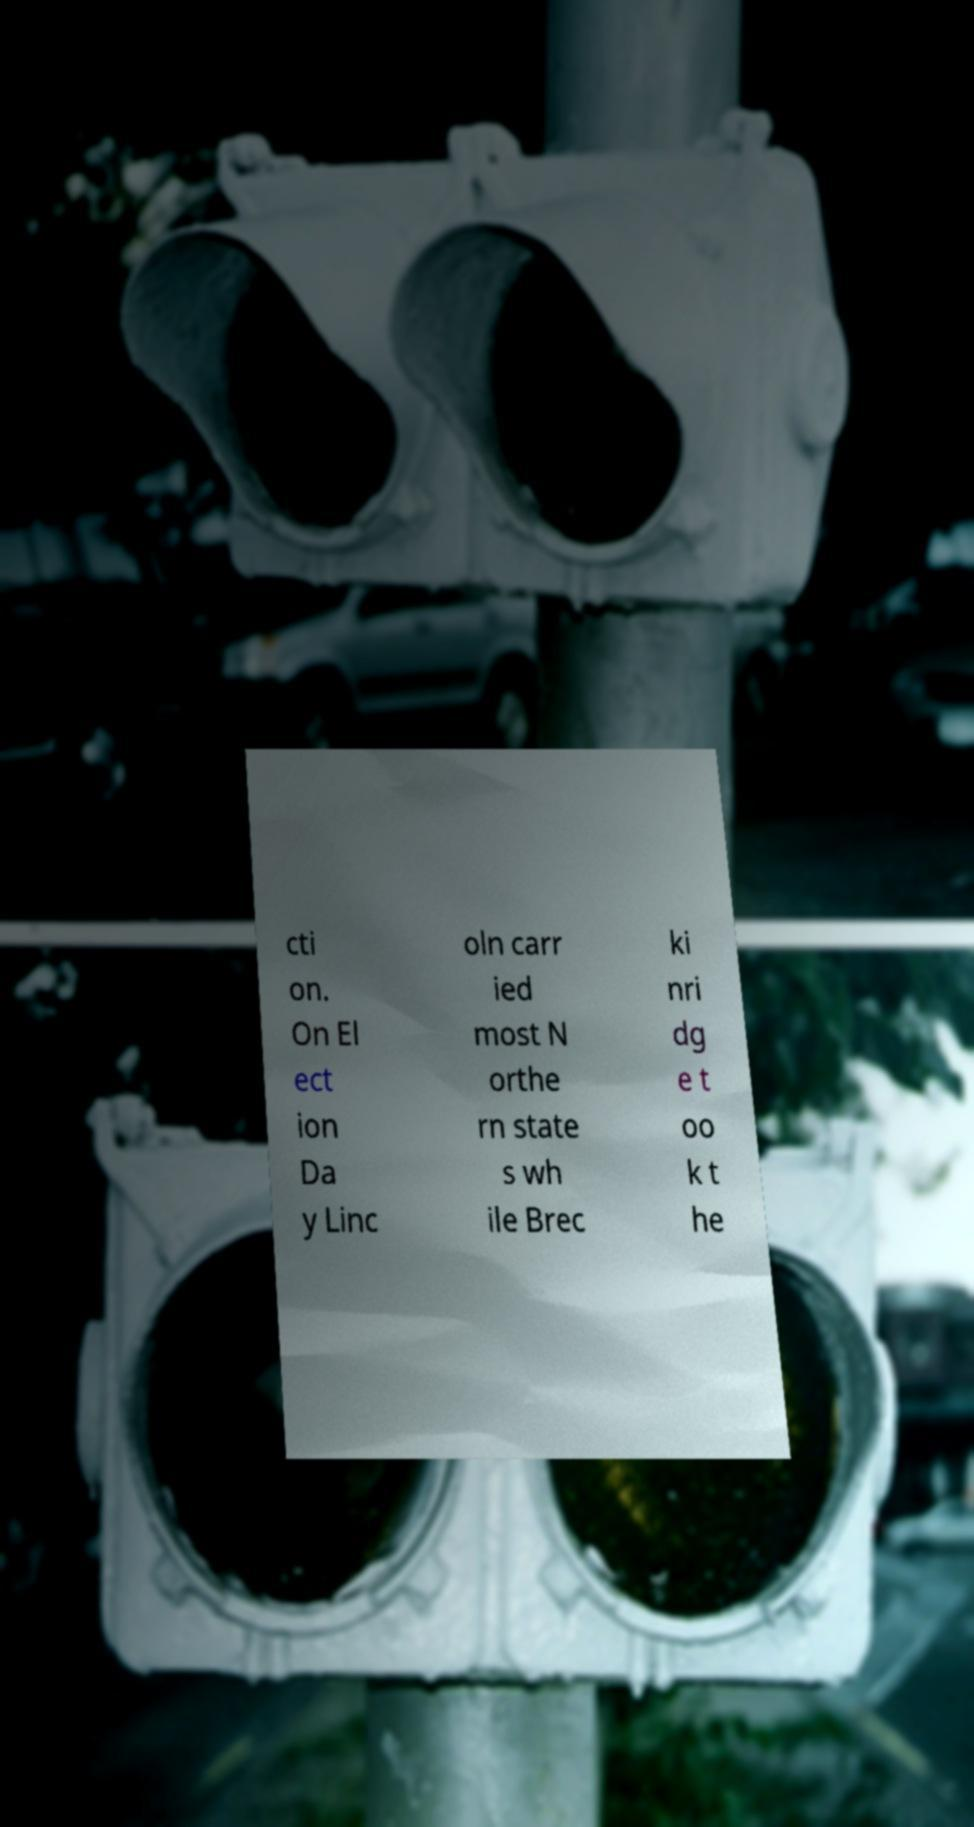Please read and relay the text visible in this image. What does it say? cti on. On El ect ion Da y Linc oln carr ied most N orthe rn state s wh ile Brec ki nri dg e t oo k t he 